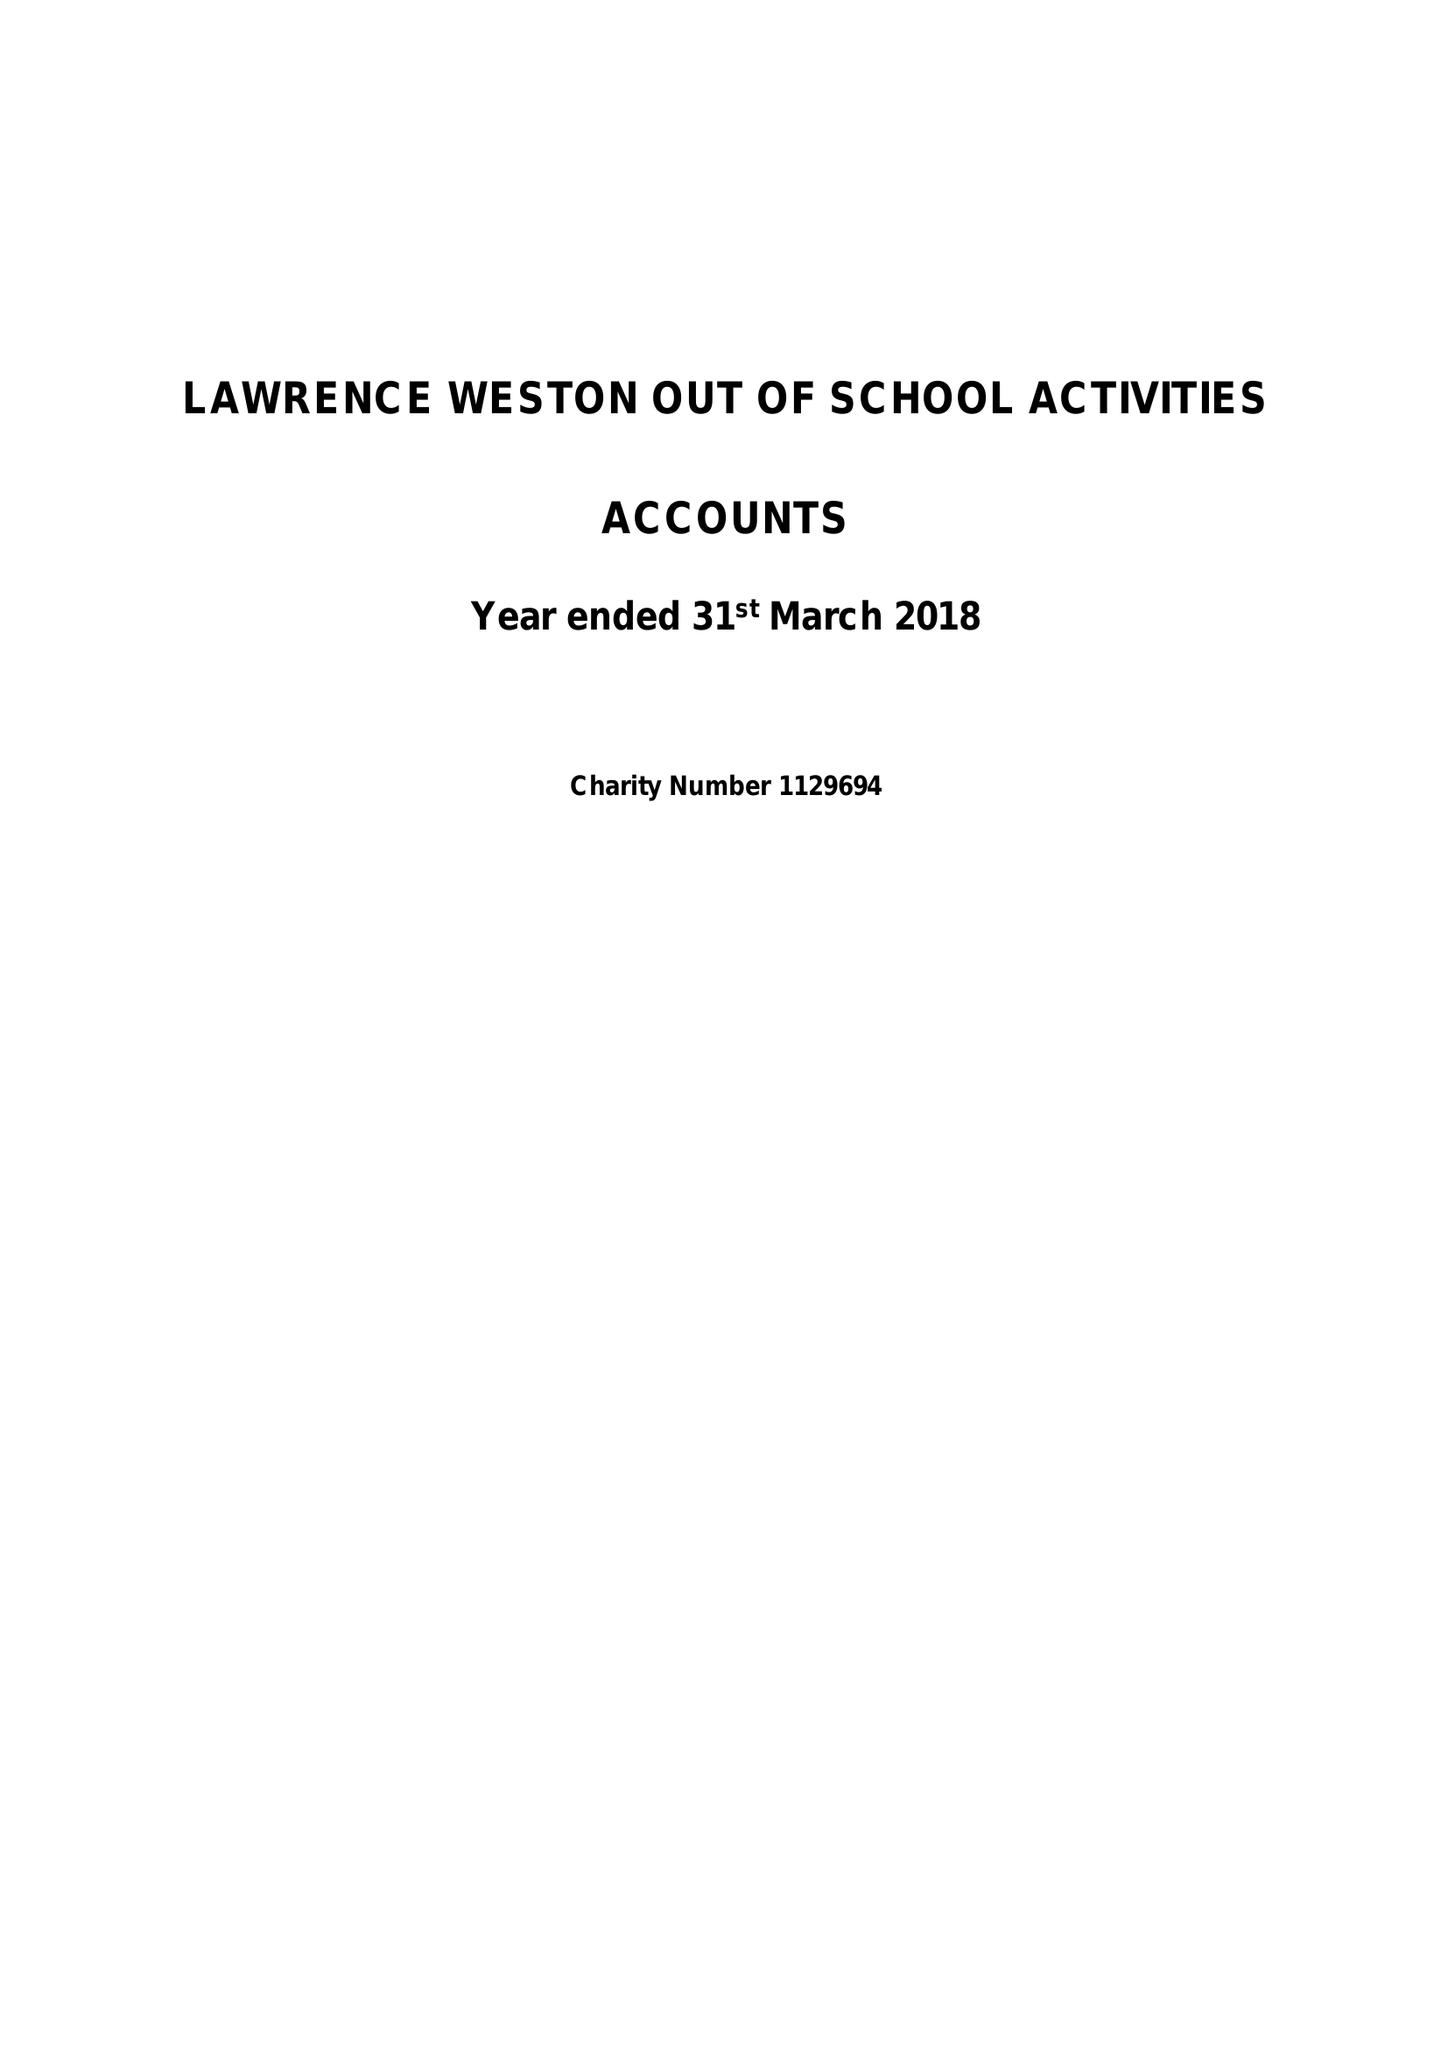What is the value for the address__post_town?
Answer the question using a single word or phrase. BRISTOL 